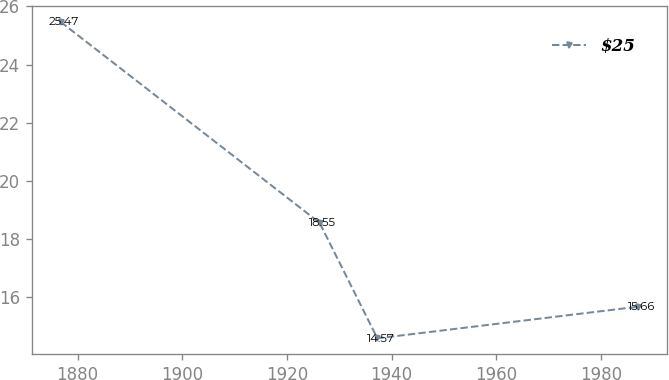<chart> <loc_0><loc_0><loc_500><loc_500><line_chart><ecel><fcel>$25<nl><fcel>1876.75<fcel>25.47<nl><fcel>1926.23<fcel>18.55<nl><fcel>1937.27<fcel>14.57<nl><fcel>1987.13<fcel>15.66<nl></chart> 